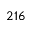<formula> <loc_0><loc_0><loc_500><loc_500>2 1 6</formula> 